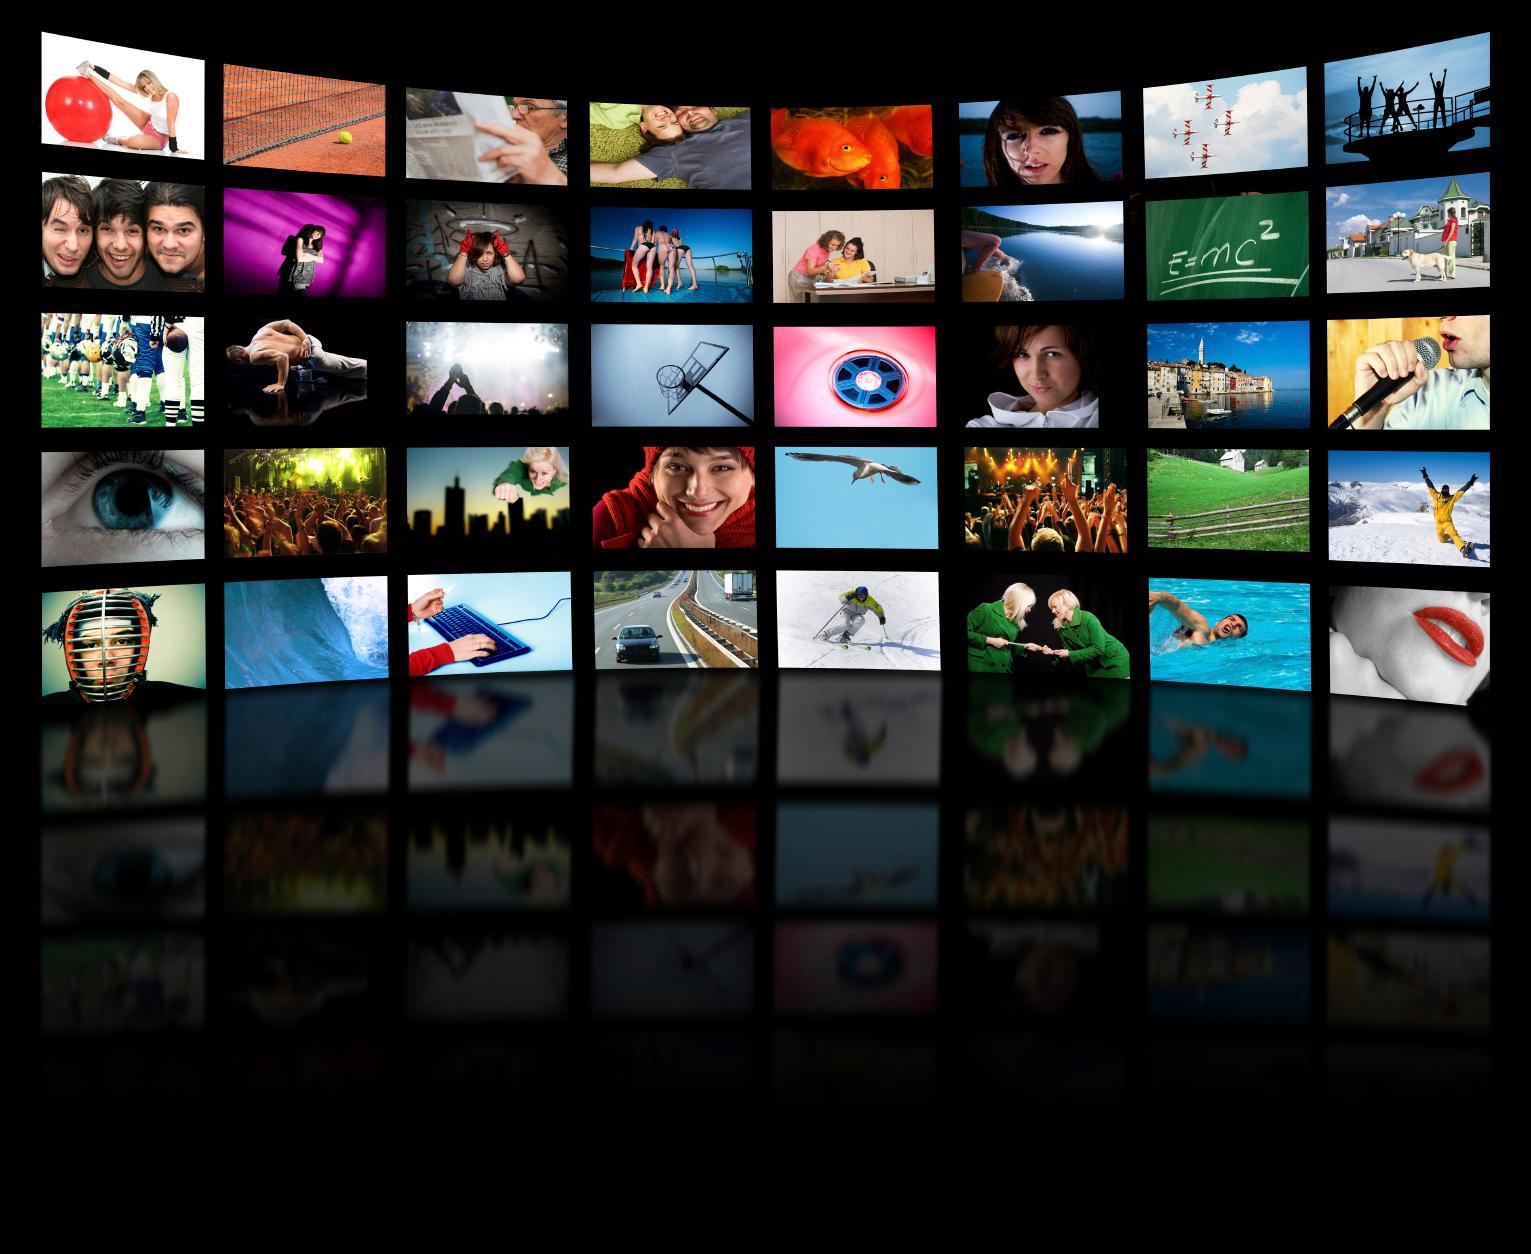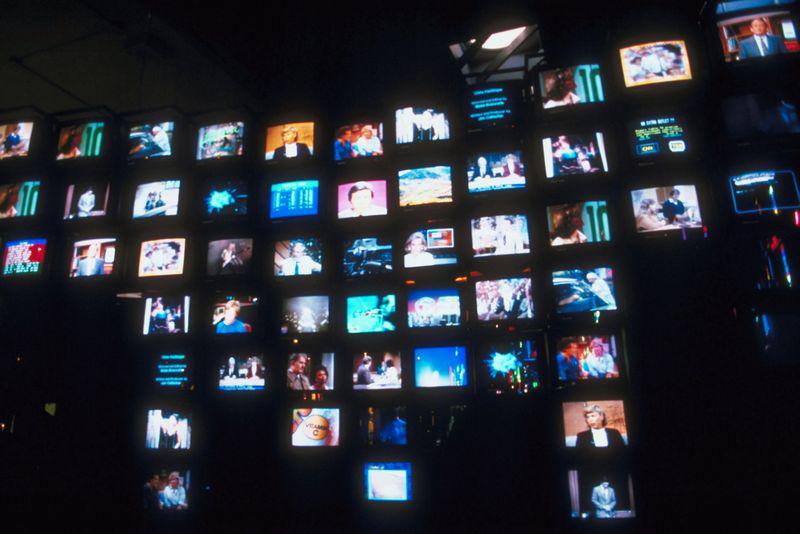The first image is the image on the left, the second image is the image on the right. Assess this claim about the two images: "An image shows a silhouetted person surrounded by glowing white light and facing a wall of screens filled with pictures.". Correct or not? Answer yes or no. No. The first image is the image on the left, the second image is the image on the right. Analyze the images presented: Is the assertion "A person is standing in front of the screen in the image on the left." valid? Answer yes or no. No. 